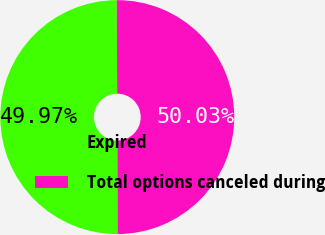<chart> <loc_0><loc_0><loc_500><loc_500><pie_chart><fcel>Expired<fcel>Total options canceled during<nl><fcel>49.97%<fcel>50.03%<nl></chart> 